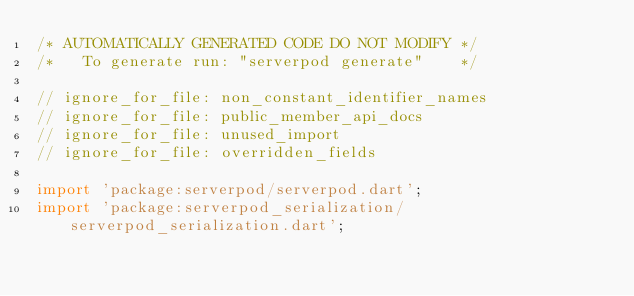Convert code to text. <code><loc_0><loc_0><loc_500><loc_500><_Dart_>/* AUTOMATICALLY GENERATED CODE DO NOT MODIFY */
/*   To generate run: "serverpod generate"    */

// ignore_for_file: non_constant_identifier_names
// ignore_for_file: public_member_api_docs
// ignore_for_file: unused_import
// ignore_for_file: overridden_fields

import 'package:serverpod/serverpod.dart';
import 'package:serverpod_serialization/serverpod_serialization.dart';</code> 